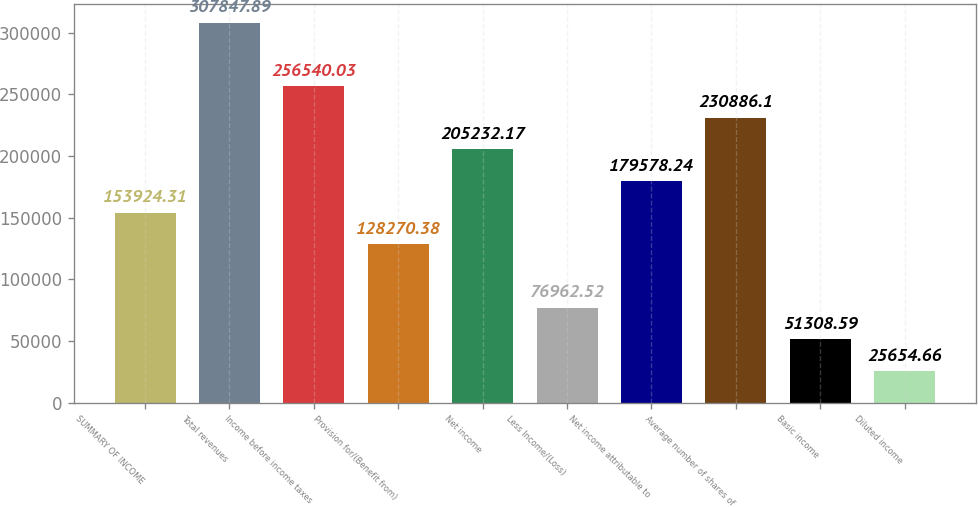Convert chart. <chart><loc_0><loc_0><loc_500><loc_500><bar_chart><fcel>SUMMARY OF INCOME<fcel>Total revenues<fcel>Income before income taxes<fcel>Provision for/(Benefit from)<fcel>Net income<fcel>Less Income/(Loss)<fcel>Net income attributable to<fcel>Average number of shares of<fcel>Basic income<fcel>Diluted income<nl><fcel>153924<fcel>307848<fcel>256540<fcel>128270<fcel>205232<fcel>76962.5<fcel>179578<fcel>230886<fcel>51308.6<fcel>25654.7<nl></chart> 